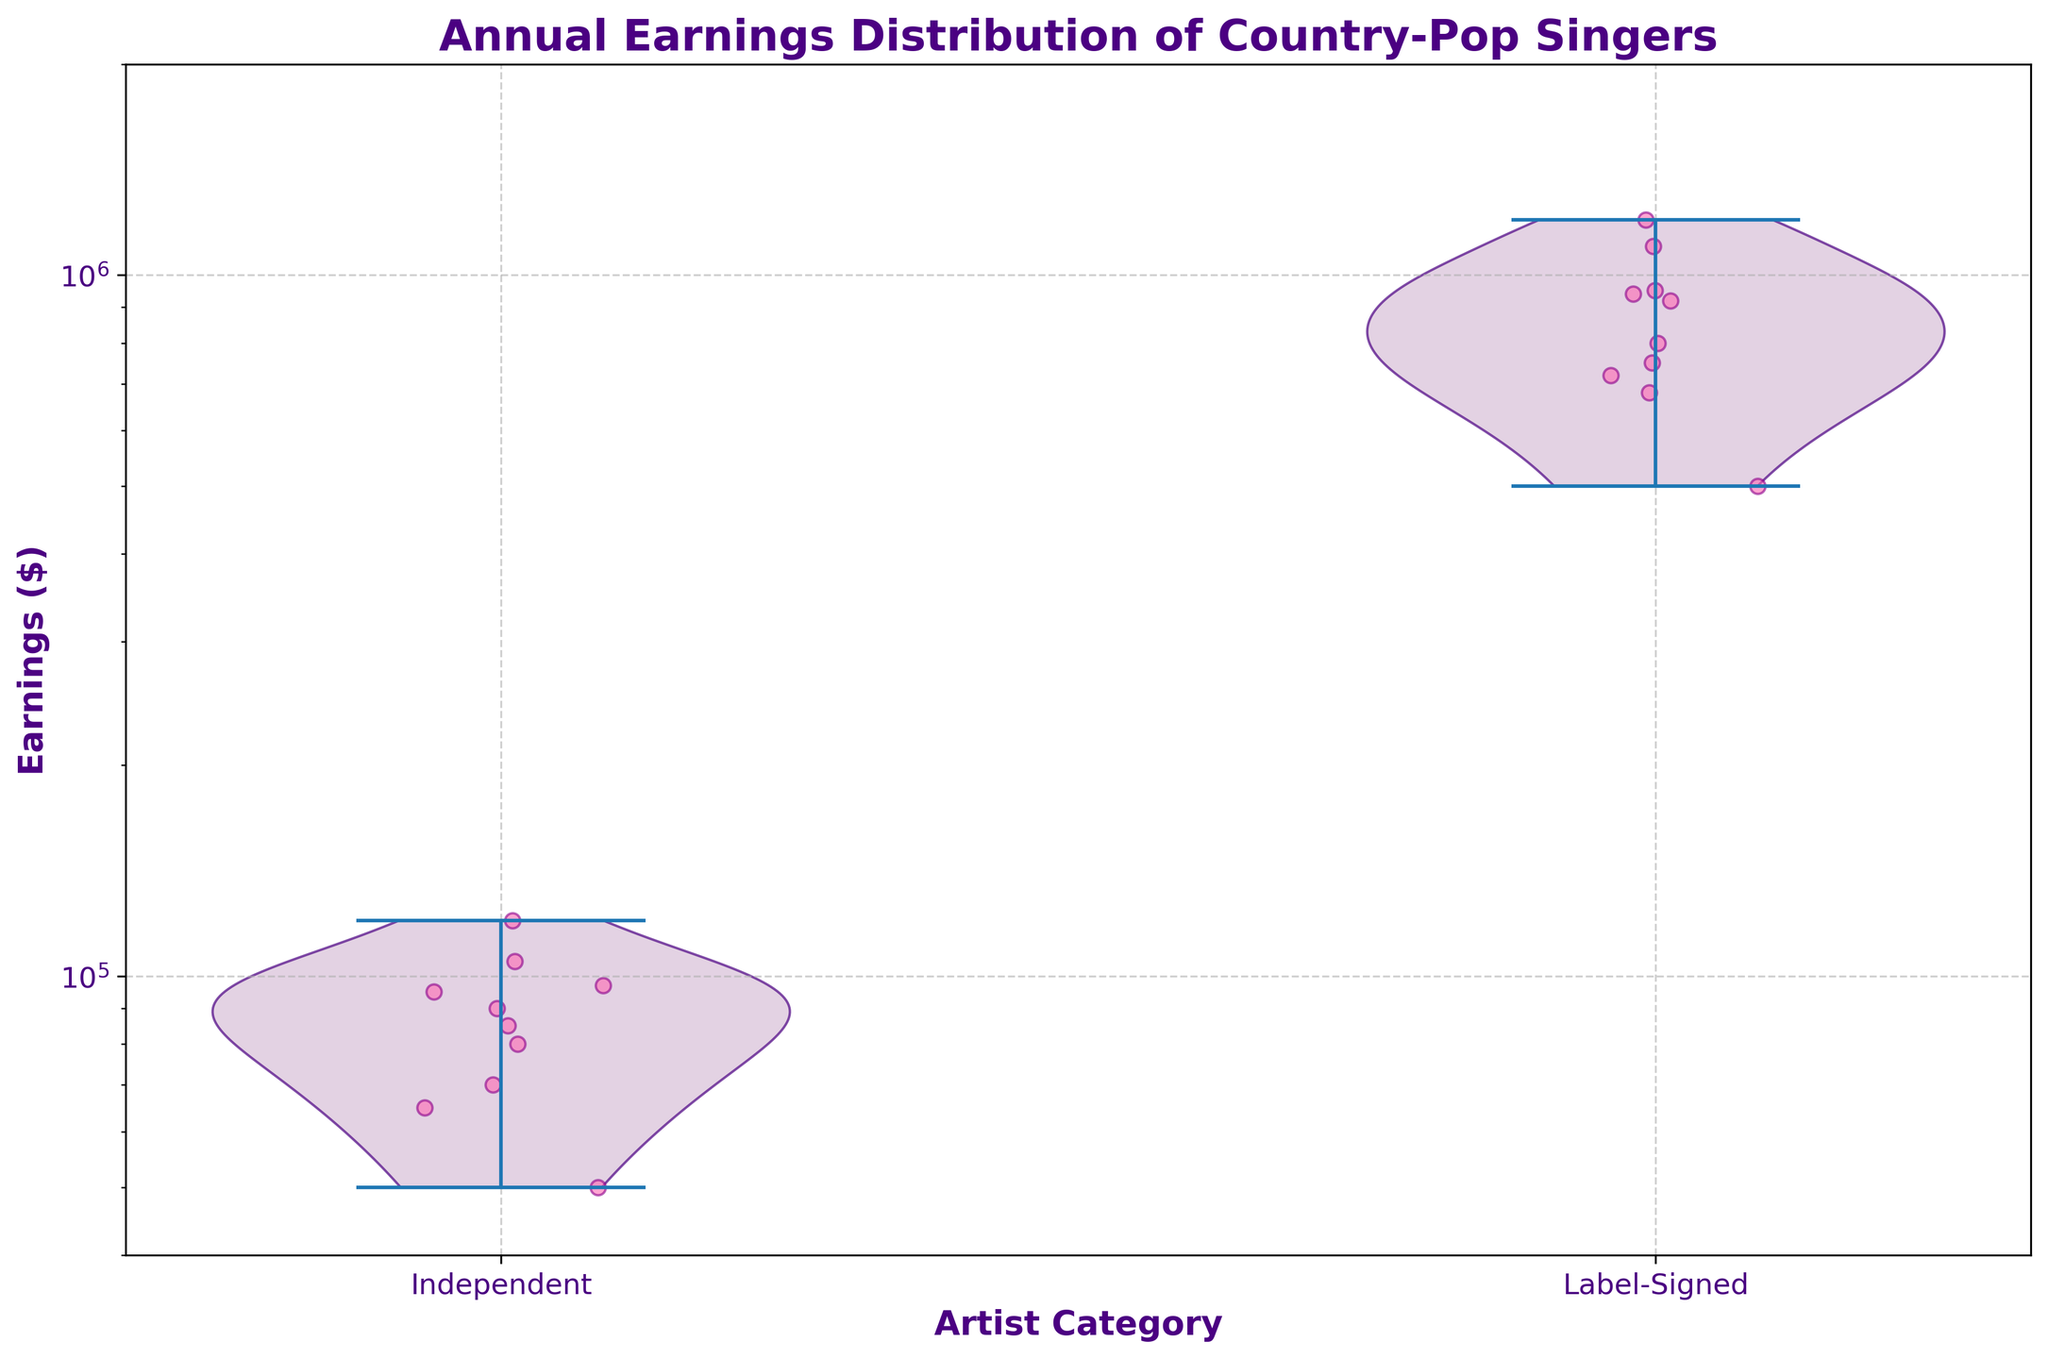what is the title of the plot? The title is written in larger, bold text at the top of the plot. It reads "Annual Earnings Distribution of Country-Pop Singers".
Answer: Annual Earnings Distribution of Country-Pop Singers how many artist categories are there? By observing the x-axis labels, there are two categories labeled as "Independent" and "Label-Signed".
Answer: 2 which category has a wider distribution of earnings? By analyzing the width of the violin plots, the "Label-Signed" category shows a wider distribution compared to the "Independent" category.
Answer: Label-Signed what is the range of earnings for independent artists? The violin plot for "Independent" artists shows earnings spread approximately from 40,000 to 120,000 dollars.
Answer: 40,000 to 120,000 dollars is the scatter plot more dense for independent or label-signed artists? Comparing the concentration of jittered points between the two categories, "Label-Signed" artists have a denser scatter plot.
Answer: Label-Signed what is the midpoint of the y-axis? With the y-axis spanning from 40,000 to 2,000,000 dollars, the midpoint can be approximated using logarithmic scaling at 200,000 dollars.
Answer: 200,000 dollars what is the earnings range that both categories have in common? Both "Independent" and "Label-Signed" categories include earnings in the 90,000 to 120,000 dollars range, as evidenced by overlapping violin plot sections and scatter points.
Answer: 90,000 to 120,000 dollars which artist category exhibits higher earnings? The earnings for "Label-Signed" artists extend to a higher maximum value as shown in the violin plot, indicating they exhibit higher earnings overall.
Answer: Label-Signed what does the color of the scatter points represent? The scatter points in the plot are uniformly colored in pink, which does not convey additional information beyond marking individual data points.
Answer: No specific information do more independent or label-signed artists make earnings near 100,000 dollars? By looking at the density of scatter points around the 100,000 dollars mark, there are more "Independent" artists than "Label-Signed" artists at this earnings level.
Answer: Independent 